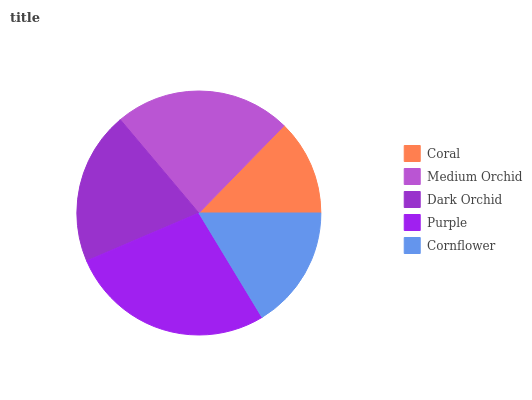Is Coral the minimum?
Answer yes or no. Yes. Is Purple the maximum?
Answer yes or no. Yes. Is Medium Orchid the minimum?
Answer yes or no. No. Is Medium Orchid the maximum?
Answer yes or no. No. Is Medium Orchid greater than Coral?
Answer yes or no. Yes. Is Coral less than Medium Orchid?
Answer yes or no. Yes. Is Coral greater than Medium Orchid?
Answer yes or no. No. Is Medium Orchid less than Coral?
Answer yes or no. No. Is Dark Orchid the high median?
Answer yes or no. Yes. Is Dark Orchid the low median?
Answer yes or no. Yes. Is Purple the high median?
Answer yes or no. No. Is Coral the low median?
Answer yes or no. No. 